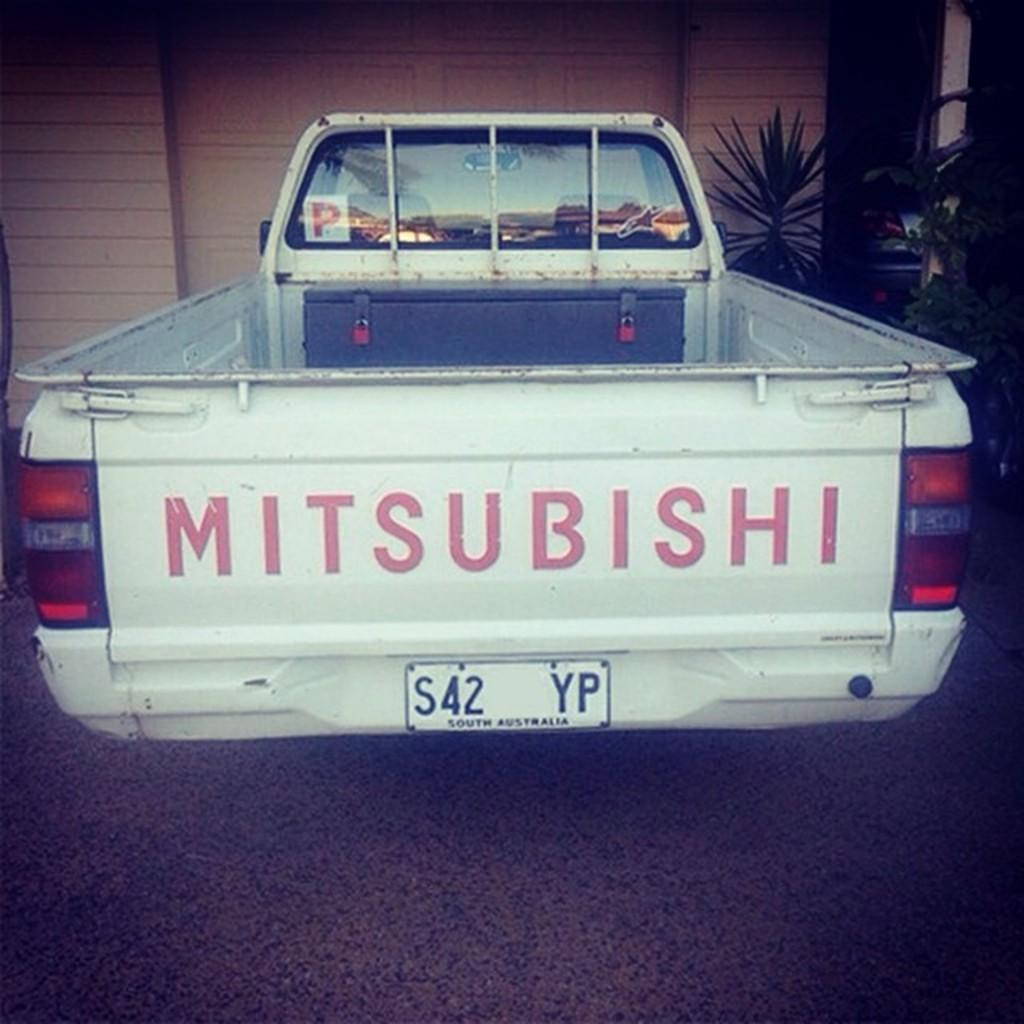What type of vehicle is in the image? There is a vehicle in the image, but the specific type is not mentioned. What color is the vehicle? The vehicle is white in color. Where is the vehicle located in the image? The vehicle is on the floor. What can be seen in the background of the image? There are trees, another car, and a building in the background of the image. What type of waves can be seen in the image? There are no waves present in the image; it features a vehicle on the floor with a background that includes trees, another car, and a building. What does the image smell like? The image does not have a smell, as it is a visual representation. 